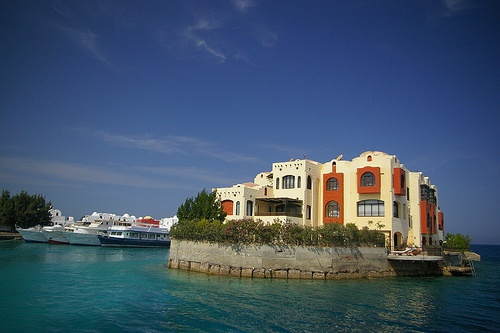Describe the objects in this image and their specific colors. I can see boat in navy, black, gray, and purple tones, boat in navy, black, darkgray, and gray tones, boat in navy, teal, black, and gray tones, and boat in navy, darkgray, gray, and lightgray tones in this image. 